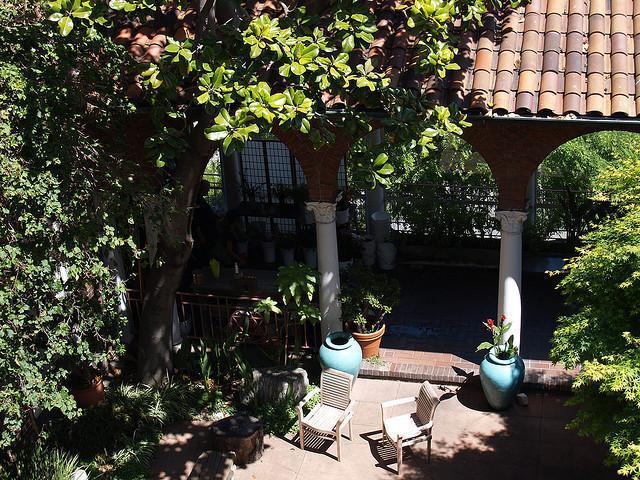How many pots are on the patio?
Give a very brief answer. 3. How many chairs can be seen?
Give a very brief answer. 2. How many potted plants can be seen?
Give a very brief answer. 6. 